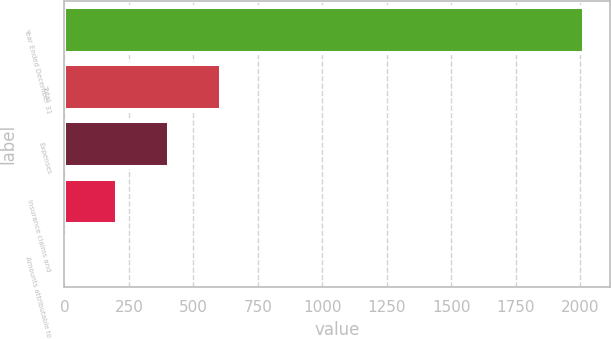<chart> <loc_0><loc_0><loc_500><loc_500><bar_chart><fcel>Year Ended December 31<fcel>Total<fcel>Expenses<fcel>Insurance claims and<fcel>Amounts attributable to<nl><fcel>2013<fcel>605.3<fcel>404.2<fcel>203.1<fcel>2<nl></chart> 